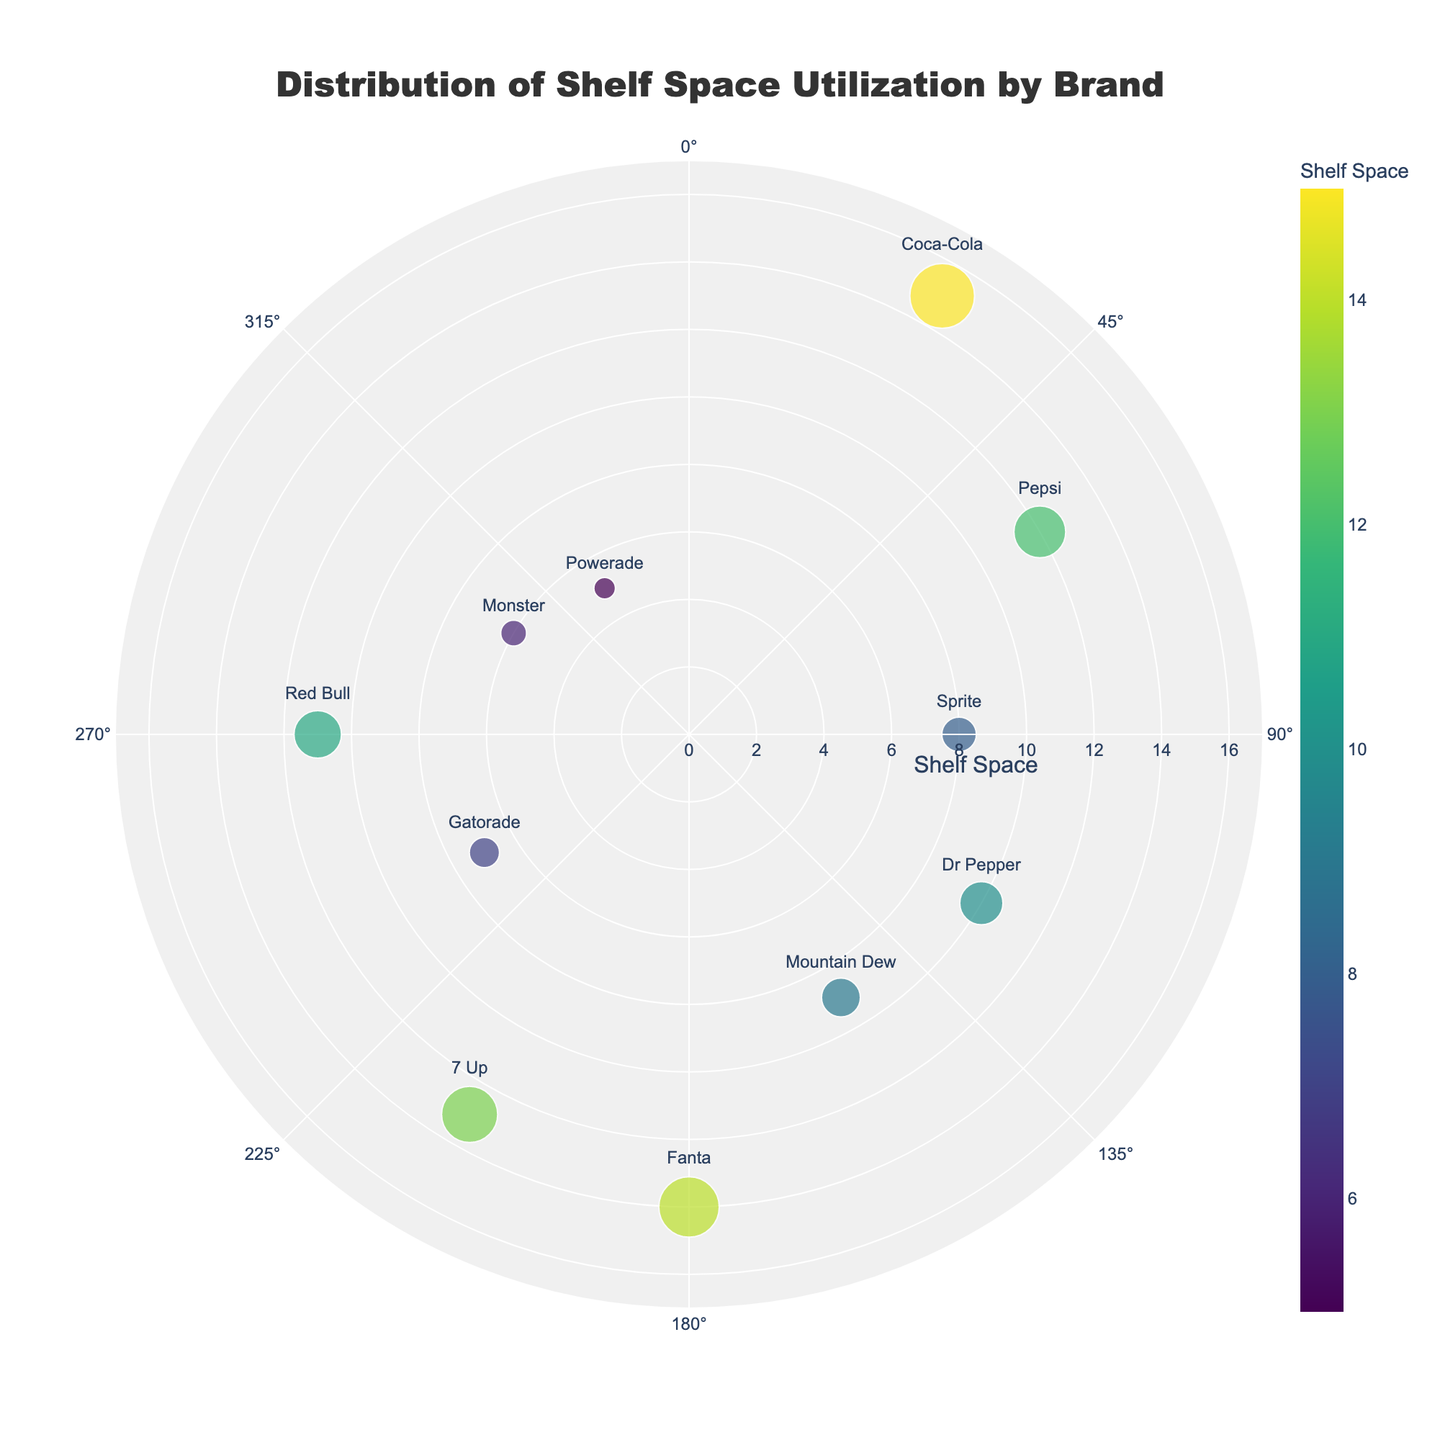What is the title of the plot? The title is positioned at the top center of the plot. It reads "Distribution of Shelf Space Utilization by Brand".
Answer: Distribution of Shelf Space Utilization by Brand Which brand has the largest shelf space? Look for the brand name that is farthest from the center on the radial axis. "Coca-Cola" has the highest value at 15.
Answer: Coca-Cola How many brands are plotted on the chart? Count the number of different brands identified by their positions and labels in the plot. There are 11 brands.
Answer: 11 What shelf space is allocated to Pepsi? Locate the "Pepsi" label in the plot and check its radial distance. "Pepsi" is at a radial distance of 12.
Answer: 12 Which brand has the smallest shelf space, and what is the space value? Identify the brand closest to the center on the radial axis. "Powerade" is the closest with a value of 5.
Answer: Powerade, 5 What is the total shelf space for Sprite and Dr Pepper? Find the radial distances for both "Sprite" (8) and "Dr Pepper" (10), then sum them up (8 + 10 = 18).
Answer: 18 Which brand is positioned at a 270-degree angle? Check the labels at the angular position of 270 degrees. "Red Bull" is located at 270 degrees.
Answer: Red Bull How does the shelf space of Mountain Dew compare to that of Sprite? Compare their radial distances. "Mountain Dew" has 9, while "Sprite" has 8. Thus, Mountain Dew has 1 more shelf space than Sprite.
Answer: Mountain Dew has 1 more What is the average shelf space of all brands? Sum all shelf space values (15 + 12 + 8 + 10 + 9 + 14 + 13 + 7 + 11 + 6 + 5 = 110) and divide by the number of brands (11). The average is 110/11 = 10.
Answer: 10 Which brands have a shelf space greater than 10? Identify brands with radial distances greater than 10. "Coca-Cola" (15), "Pepsi" (12), "Fanta" (14), "7 Up" (13), and "Red Bull" (11) have shelf spaces greater than 10.
Answer: Coca-Cola, Pepsi, Fanta, 7 Up, Red Bull 